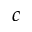<formula> <loc_0><loc_0><loc_500><loc_500>c</formula> 